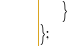<code> <loc_0><loc_0><loc_500><loc_500><_JavaScript_>    }
};
</code> 